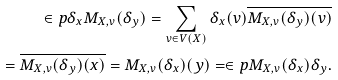<formula> <loc_0><loc_0><loc_500><loc_500>\in p { \delta _ { x } } { M _ { X , v } ( \delta _ { y } ) } = \sum _ { v \in V ( X ) } \delta _ { x } ( v ) \overline { M _ { X , v } ( \delta _ { y } ) ( v ) } \\ = \overline { M _ { X , v } ( \delta _ { y } ) ( x ) } = M _ { X , v } ( \delta _ { x } ) ( y ) = \in p { M _ { X , v } ( \delta _ { x } ) } { \delta _ { y } } .</formula> 